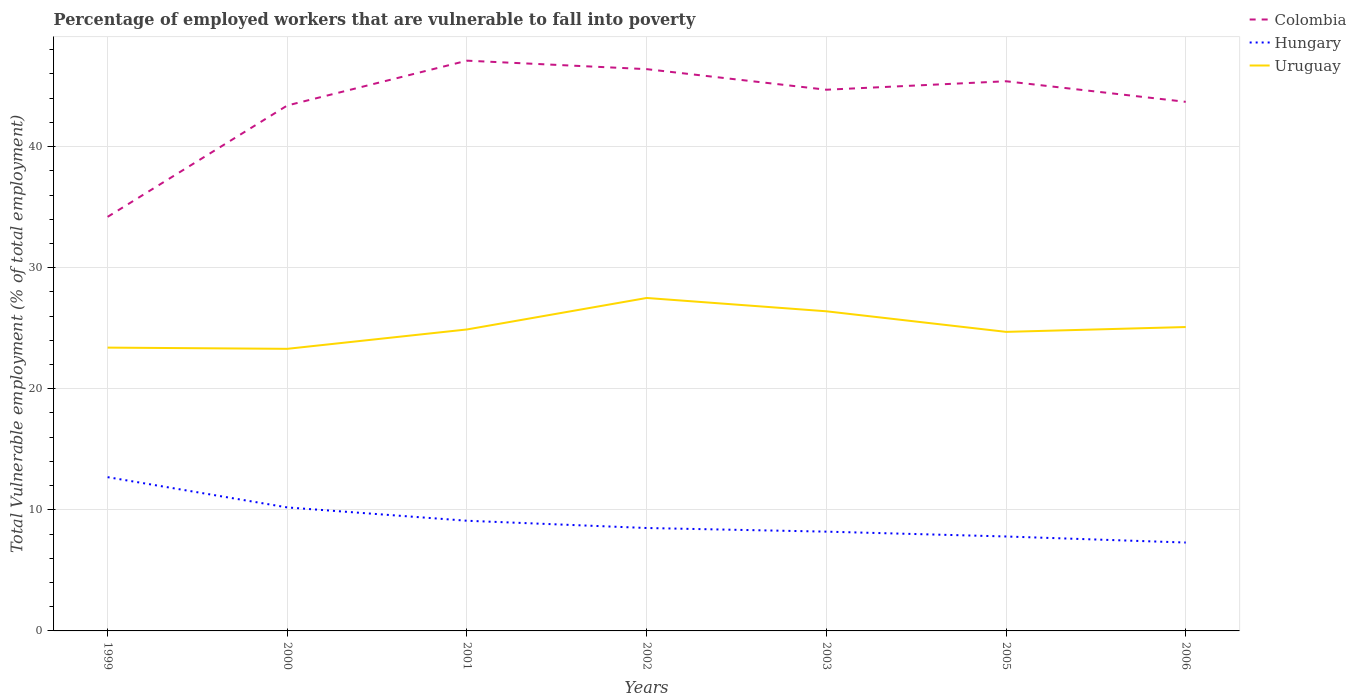How many different coloured lines are there?
Offer a terse response. 3. Does the line corresponding to Colombia intersect with the line corresponding to Hungary?
Offer a very short reply. No. Is the number of lines equal to the number of legend labels?
Ensure brevity in your answer.  Yes. Across all years, what is the maximum percentage of employed workers who are vulnerable to fall into poverty in Uruguay?
Your response must be concise. 23.3. In which year was the percentage of employed workers who are vulnerable to fall into poverty in Colombia maximum?
Offer a very short reply. 1999. What is the total percentage of employed workers who are vulnerable to fall into poverty in Uruguay in the graph?
Your answer should be compact. 1.1. What is the difference between the highest and the second highest percentage of employed workers who are vulnerable to fall into poverty in Hungary?
Offer a very short reply. 5.4. How many years are there in the graph?
Keep it short and to the point. 7. What is the difference between two consecutive major ticks on the Y-axis?
Offer a terse response. 10. Does the graph contain grids?
Keep it short and to the point. Yes. Where does the legend appear in the graph?
Your response must be concise. Top right. How are the legend labels stacked?
Give a very brief answer. Vertical. What is the title of the graph?
Provide a short and direct response. Percentage of employed workers that are vulnerable to fall into poverty. Does "India" appear as one of the legend labels in the graph?
Give a very brief answer. No. What is the label or title of the Y-axis?
Offer a terse response. Total Vulnerable employment (% of total employment). What is the Total Vulnerable employment (% of total employment) in Colombia in 1999?
Give a very brief answer. 34.2. What is the Total Vulnerable employment (% of total employment) in Hungary in 1999?
Provide a succinct answer. 12.7. What is the Total Vulnerable employment (% of total employment) of Uruguay in 1999?
Your answer should be very brief. 23.4. What is the Total Vulnerable employment (% of total employment) of Colombia in 2000?
Keep it short and to the point. 43.4. What is the Total Vulnerable employment (% of total employment) in Hungary in 2000?
Your response must be concise. 10.2. What is the Total Vulnerable employment (% of total employment) in Uruguay in 2000?
Keep it short and to the point. 23.3. What is the Total Vulnerable employment (% of total employment) of Colombia in 2001?
Make the answer very short. 47.1. What is the Total Vulnerable employment (% of total employment) of Hungary in 2001?
Give a very brief answer. 9.1. What is the Total Vulnerable employment (% of total employment) in Uruguay in 2001?
Keep it short and to the point. 24.9. What is the Total Vulnerable employment (% of total employment) of Colombia in 2002?
Offer a terse response. 46.4. What is the Total Vulnerable employment (% of total employment) in Hungary in 2002?
Provide a succinct answer. 8.5. What is the Total Vulnerable employment (% of total employment) in Colombia in 2003?
Ensure brevity in your answer.  44.7. What is the Total Vulnerable employment (% of total employment) of Hungary in 2003?
Make the answer very short. 8.2. What is the Total Vulnerable employment (% of total employment) in Uruguay in 2003?
Make the answer very short. 26.4. What is the Total Vulnerable employment (% of total employment) in Colombia in 2005?
Provide a succinct answer. 45.4. What is the Total Vulnerable employment (% of total employment) of Hungary in 2005?
Provide a short and direct response. 7.8. What is the Total Vulnerable employment (% of total employment) in Uruguay in 2005?
Your answer should be very brief. 24.7. What is the Total Vulnerable employment (% of total employment) in Colombia in 2006?
Keep it short and to the point. 43.7. What is the Total Vulnerable employment (% of total employment) of Hungary in 2006?
Your answer should be compact. 7.3. What is the Total Vulnerable employment (% of total employment) of Uruguay in 2006?
Ensure brevity in your answer.  25.1. Across all years, what is the maximum Total Vulnerable employment (% of total employment) of Colombia?
Offer a terse response. 47.1. Across all years, what is the maximum Total Vulnerable employment (% of total employment) in Hungary?
Make the answer very short. 12.7. Across all years, what is the maximum Total Vulnerable employment (% of total employment) of Uruguay?
Provide a short and direct response. 27.5. Across all years, what is the minimum Total Vulnerable employment (% of total employment) in Colombia?
Your response must be concise. 34.2. Across all years, what is the minimum Total Vulnerable employment (% of total employment) in Hungary?
Offer a very short reply. 7.3. Across all years, what is the minimum Total Vulnerable employment (% of total employment) in Uruguay?
Your answer should be compact. 23.3. What is the total Total Vulnerable employment (% of total employment) of Colombia in the graph?
Provide a short and direct response. 304.9. What is the total Total Vulnerable employment (% of total employment) of Hungary in the graph?
Your response must be concise. 63.8. What is the total Total Vulnerable employment (% of total employment) in Uruguay in the graph?
Offer a terse response. 175.3. What is the difference between the Total Vulnerable employment (% of total employment) of Colombia in 1999 and that in 2000?
Ensure brevity in your answer.  -9.2. What is the difference between the Total Vulnerable employment (% of total employment) of Uruguay in 1999 and that in 2000?
Ensure brevity in your answer.  0.1. What is the difference between the Total Vulnerable employment (% of total employment) of Colombia in 1999 and that in 2001?
Provide a short and direct response. -12.9. What is the difference between the Total Vulnerable employment (% of total employment) of Hungary in 1999 and that in 2001?
Ensure brevity in your answer.  3.6. What is the difference between the Total Vulnerable employment (% of total employment) in Colombia in 1999 and that in 2002?
Your response must be concise. -12.2. What is the difference between the Total Vulnerable employment (% of total employment) in Hungary in 1999 and that in 2002?
Your answer should be very brief. 4.2. What is the difference between the Total Vulnerable employment (% of total employment) in Uruguay in 1999 and that in 2002?
Keep it short and to the point. -4.1. What is the difference between the Total Vulnerable employment (% of total employment) of Colombia in 1999 and that in 2003?
Your response must be concise. -10.5. What is the difference between the Total Vulnerable employment (% of total employment) of Hungary in 1999 and that in 2005?
Offer a very short reply. 4.9. What is the difference between the Total Vulnerable employment (% of total employment) in Colombia in 1999 and that in 2006?
Your answer should be very brief. -9.5. What is the difference between the Total Vulnerable employment (% of total employment) of Hungary in 1999 and that in 2006?
Your response must be concise. 5.4. What is the difference between the Total Vulnerable employment (% of total employment) in Colombia in 2000 and that in 2001?
Provide a succinct answer. -3.7. What is the difference between the Total Vulnerable employment (% of total employment) in Hungary in 2000 and that in 2001?
Make the answer very short. 1.1. What is the difference between the Total Vulnerable employment (% of total employment) of Uruguay in 2000 and that in 2001?
Give a very brief answer. -1.6. What is the difference between the Total Vulnerable employment (% of total employment) of Colombia in 2000 and that in 2002?
Make the answer very short. -3. What is the difference between the Total Vulnerable employment (% of total employment) in Hungary in 2000 and that in 2002?
Make the answer very short. 1.7. What is the difference between the Total Vulnerable employment (% of total employment) of Uruguay in 2000 and that in 2002?
Your answer should be very brief. -4.2. What is the difference between the Total Vulnerable employment (% of total employment) in Hungary in 2000 and that in 2005?
Provide a succinct answer. 2.4. What is the difference between the Total Vulnerable employment (% of total employment) of Colombia in 2000 and that in 2006?
Offer a very short reply. -0.3. What is the difference between the Total Vulnerable employment (% of total employment) of Hungary in 2001 and that in 2002?
Give a very brief answer. 0.6. What is the difference between the Total Vulnerable employment (% of total employment) in Uruguay in 2001 and that in 2002?
Your answer should be compact. -2.6. What is the difference between the Total Vulnerable employment (% of total employment) of Colombia in 2001 and that in 2003?
Your answer should be very brief. 2.4. What is the difference between the Total Vulnerable employment (% of total employment) of Uruguay in 2001 and that in 2003?
Make the answer very short. -1.5. What is the difference between the Total Vulnerable employment (% of total employment) in Hungary in 2001 and that in 2005?
Your response must be concise. 1.3. What is the difference between the Total Vulnerable employment (% of total employment) of Uruguay in 2001 and that in 2005?
Your response must be concise. 0.2. What is the difference between the Total Vulnerable employment (% of total employment) in Uruguay in 2001 and that in 2006?
Ensure brevity in your answer.  -0.2. What is the difference between the Total Vulnerable employment (% of total employment) of Colombia in 2002 and that in 2003?
Your answer should be very brief. 1.7. What is the difference between the Total Vulnerable employment (% of total employment) in Colombia in 2002 and that in 2005?
Make the answer very short. 1. What is the difference between the Total Vulnerable employment (% of total employment) in Uruguay in 2002 and that in 2005?
Make the answer very short. 2.8. What is the difference between the Total Vulnerable employment (% of total employment) of Hungary in 2002 and that in 2006?
Provide a short and direct response. 1.2. What is the difference between the Total Vulnerable employment (% of total employment) of Hungary in 2003 and that in 2005?
Provide a short and direct response. 0.4. What is the difference between the Total Vulnerable employment (% of total employment) of Colombia in 2003 and that in 2006?
Give a very brief answer. 1. What is the difference between the Total Vulnerable employment (% of total employment) in Uruguay in 2003 and that in 2006?
Your response must be concise. 1.3. What is the difference between the Total Vulnerable employment (% of total employment) of Colombia in 2005 and that in 2006?
Your answer should be compact. 1.7. What is the difference between the Total Vulnerable employment (% of total employment) in Hungary in 2005 and that in 2006?
Offer a terse response. 0.5. What is the difference between the Total Vulnerable employment (% of total employment) in Uruguay in 2005 and that in 2006?
Provide a succinct answer. -0.4. What is the difference between the Total Vulnerable employment (% of total employment) of Colombia in 1999 and the Total Vulnerable employment (% of total employment) of Hungary in 2000?
Your answer should be very brief. 24. What is the difference between the Total Vulnerable employment (% of total employment) in Colombia in 1999 and the Total Vulnerable employment (% of total employment) in Uruguay in 2000?
Your answer should be very brief. 10.9. What is the difference between the Total Vulnerable employment (% of total employment) of Hungary in 1999 and the Total Vulnerable employment (% of total employment) of Uruguay in 2000?
Provide a succinct answer. -10.6. What is the difference between the Total Vulnerable employment (% of total employment) in Colombia in 1999 and the Total Vulnerable employment (% of total employment) in Hungary in 2001?
Ensure brevity in your answer.  25.1. What is the difference between the Total Vulnerable employment (% of total employment) in Hungary in 1999 and the Total Vulnerable employment (% of total employment) in Uruguay in 2001?
Give a very brief answer. -12.2. What is the difference between the Total Vulnerable employment (% of total employment) of Colombia in 1999 and the Total Vulnerable employment (% of total employment) of Hungary in 2002?
Provide a short and direct response. 25.7. What is the difference between the Total Vulnerable employment (% of total employment) of Colombia in 1999 and the Total Vulnerable employment (% of total employment) of Uruguay in 2002?
Your answer should be compact. 6.7. What is the difference between the Total Vulnerable employment (% of total employment) in Hungary in 1999 and the Total Vulnerable employment (% of total employment) in Uruguay in 2002?
Ensure brevity in your answer.  -14.8. What is the difference between the Total Vulnerable employment (% of total employment) of Colombia in 1999 and the Total Vulnerable employment (% of total employment) of Hungary in 2003?
Offer a terse response. 26. What is the difference between the Total Vulnerable employment (% of total employment) in Hungary in 1999 and the Total Vulnerable employment (% of total employment) in Uruguay in 2003?
Offer a very short reply. -13.7. What is the difference between the Total Vulnerable employment (% of total employment) of Colombia in 1999 and the Total Vulnerable employment (% of total employment) of Hungary in 2005?
Ensure brevity in your answer.  26.4. What is the difference between the Total Vulnerable employment (% of total employment) of Hungary in 1999 and the Total Vulnerable employment (% of total employment) of Uruguay in 2005?
Give a very brief answer. -12. What is the difference between the Total Vulnerable employment (% of total employment) of Colombia in 1999 and the Total Vulnerable employment (% of total employment) of Hungary in 2006?
Your answer should be compact. 26.9. What is the difference between the Total Vulnerable employment (% of total employment) of Colombia in 1999 and the Total Vulnerable employment (% of total employment) of Uruguay in 2006?
Make the answer very short. 9.1. What is the difference between the Total Vulnerable employment (% of total employment) in Colombia in 2000 and the Total Vulnerable employment (% of total employment) in Hungary in 2001?
Offer a terse response. 34.3. What is the difference between the Total Vulnerable employment (% of total employment) of Hungary in 2000 and the Total Vulnerable employment (% of total employment) of Uruguay in 2001?
Offer a terse response. -14.7. What is the difference between the Total Vulnerable employment (% of total employment) in Colombia in 2000 and the Total Vulnerable employment (% of total employment) in Hungary in 2002?
Give a very brief answer. 34.9. What is the difference between the Total Vulnerable employment (% of total employment) in Colombia in 2000 and the Total Vulnerable employment (% of total employment) in Uruguay in 2002?
Offer a very short reply. 15.9. What is the difference between the Total Vulnerable employment (% of total employment) of Hungary in 2000 and the Total Vulnerable employment (% of total employment) of Uruguay in 2002?
Give a very brief answer. -17.3. What is the difference between the Total Vulnerable employment (% of total employment) in Colombia in 2000 and the Total Vulnerable employment (% of total employment) in Hungary in 2003?
Offer a very short reply. 35.2. What is the difference between the Total Vulnerable employment (% of total employment) of Colombia in 2000 and the Total Vulnerable employment (% of total employment) of Uruguay in 2003?
Your answer should be very brief. 17. What is the difference between the Total Vulnerable employment (% of total employment) of Hungary in 2000 and the Total Vulnerable employment (% of total employment) of Uruguay in 2003?
Offer a very short reply. -16.2. What is the difference between the Total Vulnerable employment (% of total employment) of Colombia in 2000 and the Total Vulnerable employment (% of total employment) of Hungary in 2005?
Make the answer very short. 35.6. What is the difference between the Total Vulnerable employment (% of total employment) of Colombia in 2000 and the Total Vulnerable employment (% of total employment) of Uruguay in 2005?
Offer a very short reply. 18.7. What is the difference between the Total Vulnerable employment (% of total employment) in Hungary in 2000 and the Total Vulnerable employment (% of total employment) in Uruguay in 2005?
Your response must be concise. -14.5. What is the difference between the Total Vulnerable employment (% of total employment) of Colombia in 2000 and the Total Vulnerable employment (% of total employment) of Hungary in 2006?
Offer a terse response. 36.1. What is the difference between the Total Vulnerable employment (% of total employment) of Colombia in 2000 and the Total Vulnerable employment (% of total employment) of Uruguay in 2006?
Ensure brevity in your answer.  18.3. What is the difference between the Total Vulnerable employment (% of total employment) in Hungary in 2000 and the Total Vulnerable employment (% of total employment) in Uruguay in 2006?
Provide a succinct answer. -14.9. What is the difference between the Total Vulnerable employment (% of total employment) in Colombia in 2001 and the Total Vulnerable employment (% of total employment) in Hungary in 2002?
Your response must be concise. 38.6. What is the difference between the Total Vulnerable employment (% of total employment) in Colombia in 2001 and the Total Vulnerable employment (% of total employment) in Uruguay in 2002?
Your response must be concise. 19.6. What is the difference between the Total Vulnerable employment (% of total employment) in Hungary in 2001 and the Total Vulnerable employment (% of total employment) in Uruguay in 2002?
Ensure brevity in your answer.  -18.4. What is the difference between the Total Vulnerable employment (% of total employment) in Colombia in 2001 and the Total Vulnerable employment (% of total employment) in Hungary in 2003?
Your answer should be very brief. 38.9. What is the difference between the Total Vulnerable employment (% of total employment) of Colombia in 2001 and the Total Vulnerable employment (% of total employment) of Uruguay in 2003?
Provide a short and direct response. 20.7. What is the difference between the Total Vulnerable employment (% of total employment) of Hungary in 2001 and the Total Vulnerable employment (% of total employment) of Uruguay in 2003?
Make the answer very short. -17.3. What is the difference between the Total Vulnerable employment (% of total employment) in Colombia in 2001 and the Total Vulnerable employment (% of total employment) in Hungary in 2005?
Make the answer very short. 39.3. What is the difference between the Total Vulnerable employment (% of total employment) in Colombia in 2001 and the Total Vulnerable employment (% of total employment) in Uruguay in 2005?
Provide a short and direct response. 22.4. What is the difference between the Total Vulnerable employment (% of total employment) in Hungary in 2001 and the Total Vulnerable employment (% of total employment) in Uruguay in 2005?
Give a very brief answer. -15.6. What is the difference between the Total Vulnerable employment (% of total employment) in Colombia in 2001 and the Total Vulnerable employment (% of total employment) in Hungary in 2006?
Provide a succinct answer. 39.8. What is the difference between the Total Vulnerable employment (% of total employment) of Hungary in 2001 and the Total Vulnerable employment (% of total employment) of Uruguay in 2006?
Your answer should be compact. -16. What is the difference between the Total Vulnerable employment (% of total employment) of Colombia in 2002 and the Total Vulnerable employment (% of total employment) of Hungary in 2003?
Provide a short and direct response. 38.2. What is the difference between the Total Vulnerable employment (% of total employment) of Colombia in 2002 and the Total Vulnerable employment (% of total employment) of Uruguay in 2003?
Provide a short and direct response. 20. What is the difference between the Total Vulnerable employment (% of total employment) of Hungary in 2002 and the Total Vulnerable employment (% of total employment) of Uruguay in 2003?
Your answer should be very brief. -17.9. What is the difference between the Total Vulnerable employment (% of total employment) of Colombia in 2002 and the Total Vulnerable employment (% of total employment) of Hungary in 2005?
Give a very brief answer. 38.6. What is the difference between the Total Vulnerable employment (% of total employment) of Colombia in 2002 and the Total Vulnerable employment (% of total employment) of Uruguay in 2005?
Your answer should be very brief. 21.7. What is the difference between the Total Vulnerable employment (% of total employment) in Hungary in 2002 and the Total Vulnerable employment (% of total employment) in Uruguay in 2005?
Give a very brief answer. -16.2. What is the difference between the Total Vulnerable employment (% of total employment) of Colombia in 2002 and the Total Vulnerable employment (% of total employment) of Hungary in 2006?
Make the answer very short. 39.1. What is the difference between the Total Vulnerable employment (% of total employment) in Colombia in 2002 and the Total Vulnerable employment (% of total employment) in Uruguay in 2006?
Your answer should be compact. 21.3. What is the difference between the Total Vulnerable employment (% of total employment) of Hungary in 2002 and the Total Vulnerable employment (% of total employment) of Uruguay in 2006?
Your answer should be compact. -16.6. What is the difference between the Total Vulnerable employment (% of total employment) in Colombia in 2003 and the Total Vulnerable employment (% of total employment) in Hungary in 2005?
Provide a short and direct response. 36.9. What is the difference between the Total Vulnerable employment (% of total employment) of Hungary in 2003 and the Total Vulnerable employment (% of total employment) of Uruguay in 2005?
Provide a succinct answer. -16.5. What is the difference between the Total Vulnerable employment (% of total employment) in Colombia in 2003 and the Total Vulnerable employment (% of total employment) in Hungary in 2006?
Give a very brief answer. 37.4. What is the difference between the Total Vulnerable employment (% of total employment) in Colombia in 2003 and the Total Vulnerable employment (% of total employment) in Uruguay in 2006?
Give a very brief answer. 19.6. What is the difference between the Total Vulnerable employment (% of total employment) of Hungary in 2003 and the Total Vulnerable employment (% of total employment) of Uruguay in 2006?
Give a very brief answer. -16.9. What is the difference between the Total Vulnerable employment (% of total employment) of Colombia in 2005 and the Total Vulnerable employment (% of total employment) of Hungary in 2006?
Keep it short and to the point. 38.1. What is the difference between the Total Vulnerable employment (% of total employment) in Colombia in 2005 and the Total Vulnerable employment (% of total employment) in Uruguay in 2006?
Your response must be concise. 20.3. What is the difference between the Total Vulnerable employment (% of total employment) of Hungary in 2005 and the Total Vulnerable employment (% of total employment) of Uruguay in 2006?
Keep it short and to the point. -17.3. What is the average Total Vulnerable employment (% of total employment) of Colombia per year?
Ensure brevity in your answer.  43.56. What is the average Total Vulnerable employment (% of total employment) of Hungary per year?
Your answer should be compact. 9.11. What is the average Total Vulnerable employment (% of total employment) in Uruguay per year?
Offer a very short reply. 25.04. In the year 1999, what is the difference between the Total Vulnerable employment (% of total employment) in Colombia and Total Vulnerable employment (% of total employment) in Hungary?
Your response must be concise. 21.5. In the year 1999, what is the difference between the Total Vulnerable employment (% of total employment) of Colombia and Total Vulnerable employment (% of total employment) of Uruguay?
Make the answer very short. 10.8. In the year 2000, what is the difference between the Total Vulnerable employment (% of total employment) of Colombia and Total Vulnerable employment (% of total employment) of Hungary?
Your answer should be very brief. 33.2. In the year 2000, what is the difference between the Total Vulnerable employment (% of total employment) of Colombia and Total Vulnerable employment (% of total employment) of Uruguay?
Offer a very short reply. 20.1. In the year 2001, what is the difference between the Total Vulnerable employment (% of total employment) in Colombia and Total Vulnerable employment (% of total employment) in Uruguay?
Ensure brevity in your answer.  22.2. In the year 2001, what is the difference between the Total Vulnerable employment (% of total employment) in Hungary and Total Vulnerable employment (% of total employment) in Uruguay?
Offer a terse response. -15.8. In the year 2002, what is the difference between the Total Vulnerable employment (% of total employment) in Colombia and Total Vulnerable employment (% of total employment) in Hungary?
Your response must be concise. 37.9. In the year 2002, what is the difference between the Total Vulnerable employment (% of total employment) in Colombia and Total Vulnerable employment (% of total employment) in Uruguay?
Offer a very short reply. 18.9. In the year 2003, what is the difference between the Total Vulnerable employment (% of total employment) of Colombia and Total Vulnerable employment (% of total employment) of Hungary?
Your response must be concise. 36.5. In the year 2003, what is the difference between the Total Vulnerable employment (% of total employment) of Hungary and Total Vulnerable employment (% of total employment) of Uruguay?
Ensure brevity in your answer.  -18.2. In the year 2005, what is the difference between the Total Vulnerable employment (% of total employment) of Colombia and Total Vulnerable employment (% of total employment) of Hungary?
Your answer should be compact. 37.6. In the year 2005, what is the difference between the Total Vulnerable employment (% of total employment) in Colombia and Total Vulnerable employment (% of total employment) in Uruguay?
Your answer should be compact. 20.7. In the year 2005, what is the difference between the Total Vulnerable employment (% of total employment) in Hungary and Total Vulnerable employment (% of total employment) in Uruguay?
Give a very brief answer. -16.9. In the year 2006, what is the difference between the Total Vulnerable employment (% of total employment) of Colombia and Total Vulnerable employment (% of total employment) of Hungary?
Give a very brief answer. 36.4. In the year 2006, what is the difference between the Total Vulnerable employment (% of total employment) of Colombia and Total Vulnerable employment (% of total employment) of Uruguay?
Offer a terse response. 18.6. In the year 2006, what is the difference between the Total Vulnerable employment (% of total employment) of Hungary and Total Vulnerable employment (% of total employment) of Uruguay?
Keep it short and to the point. -17.8. What is the ratio of the Total Vulnerable employment (% of total employment) in Colombia in 1999 to that in 2000?
Make the answer very short. 0.79. What is the ratio of the Total Vulnerable employment (% of total employment) in Hungary in 1999 to that in 2000?
Your answer should be very brief. 1.25. What is the ratio of the Total Vulnerable employment (% of total employment) in Colombia in 1999 to that in 2001?
Provide a short and direct response. 0.73. What is the ratio of the Total Vulnerable employment (% of total employment) of Hungary in 1999 to that in 2001?
Provide a short and direct response. 1.4. What is the ratio of the Total Vulnerable employment (% of total employment) of Uruguay in 1999 to that in 2001?
Give a very brief answer. 0.94. What is the ratio of the Total Vulnerable employment (% of total employment) in Colombia in 1999 to that in 2002?
Your answer should be compact. 0.74. What is the ratio of the Total Vulnerable employment (% of total employment) in Hungary in 1999 to that in 2002?
Provide a short and direct response. 1.49. What is the ratio of the Total Vulnerable employment (% of total employment) of Uruguay in 1999 to that in 2002?
Your response must be concise. 0.85. What is the ratio of the Total Vulnerable employment (% of total employment) of Colombia in 1999 to that in 2003?
Your response must be concise. 0.77. What is the ratio of the Total Vulnerable employment (% of total employment) of Hungary in 1999 to that in 2003?
Your response must be concise. 1.55. What is the ratio of the Total Vulnerable employment (% of total employment) of Uruguay in 1999 to that in 2003?
Your answer should be compact. 0.89. What is the ratio of the Total Vulnerable employment (% of total employment) of Colombia in 1999 to that in 2005?
Give a very brief answer. 0.75. What is the ratio of the Total Vulnerable employment (% of total employment) of Hungary in 1999 to that in 2005?
Provide a succinct answer. 1.63. What is the ratio of the Total Vulnerable employment (% of total employment) of Uruguay in 1999 to that in 2005?
Make the answer very short. 0.95. What is the ratio of the Total Vulnerable employment (% of total employment) of Colombia in 1999 to that in 2006?
Your answer should be compact. 0.78. What is the ratio of the Total Vulnerable employment (% of total employment) in Hungary in 1999 to that in 2006?
Offer a very short reply. 1.74. What is the ratio of the Total Vulnerable employment (% of total employment) in Uruguay in 1999 to that in 2006?
Provide a succinct answer. 0.93. What is the ratio of the Total Vulnerable employment (% of total employment) of Colombia in 2000 to that in 2001?
Provide a succinct answer. 0.92. What is the ratio of the Total Vulnerable employment (% of total employment) of Hungary in 2000 to that in 2001?
Your answer should be very brief. 1.12. What is the ratio of the Total Vulnerable employment (% of total employment) of Uruguay in 2000 to that in 2001?
Ensure brevity in your answer.  0.94. What is the ratio of the Total Vulnerable employment (% of total employment) in Colombia in 2000 to that in 2002?
Offer a terse response. 0.94. What is the ratio of the Total Vulnerable employment (% of total employment) in Uruguay in 2000 to that in 2002?
Keep it short and to the point. 0.85. What is the ratio of the Total Vulnerable employment (% of total employment) in Colombia in 2000 to that in 2003?
Offer a terse response. 0.97. What is the ratio of the Total Vulnerable employment (% of total employment) of Hungary in 2000 to that in 2003?
Make the answer very short. 1.24. What is the ratio of the Total Vulnerable employment (% of total employment) in Uruguay in 2000 to that in 2003?
Make the answer very short. 0.88. What is the ratio of the Total Vulnerable employment (% of total employment) in Colombia in 2000 to that in 2005?
Offer a terse response. 0.96. What is the ratio of the Total Vulnerable employment (% of total employment) in Hungary in 2000 to that in 2005?
Your answer should be compact. 1.31. What is the ratio of the Total Vulnerable employment (% of total employment) in Uruguay in 2000 to that in 2005?
Keep it short and to the point. 0.94. What is the ratio of the Total Vulnerable employment (% of total employment) of Colombia in 2000 to that in 2006?
Provide a succinct answer. 0.99. What is the ratio of the Total Vulnerable employment (% of total employment) of Hungary in 2000 to that in 2006?
Offer a terse response. 1.4. What is the ratio of the Total Vulnerable employment (% of total employment) of Uruguay in 2000 to that in 2006?
Provide a short and direct response. 0.93. What is the ratio of the Total Vulnerable employment (% of total employment) in Colombia in 2001 to that in 2002?
Your answer should be compact. 1.02. What is the ratio of the Total Vulnerable employment (% of total employment) of Hungary in 2001 to that in 2002?
Offer a terse response. 1.07. What is the ratio of the Total Vulnerable employment (% of total employment) in Uruguay in 2001 to that in 2002?
Your response must be concise. 0.91. What is the ratio of the Total Vulnerable employment (% of total employment) in Colombia in 2001 to that in 2003?
Provide a short and direct response. 1.05. What is the ratio of the Total Vulnerable employment (% of total employment) in Hungary in 2001 to that in 2003?
Ensure brevity in your answer.  1.11. What is the ratio of the Total Vulnerable employment (% of total employment) in Uruguay in 2001 to that in 2003?
Make the answer very short. 0.94. What is the ratio of the Total Vulnerable employment (% of total employment) in Colombia in 2001 to that in 2005?
Keep it short and to the point. 1.04. What is the ratio of the Total Vulnerable employment (% of total employment) in Hungary in 2001 to that in 2005?
Give a very brief answer. 1.17. What is the ratio of the Total Vulnerable employment (% of total employment) in Colombia in 2001 to that in 2006?
Keep it short and to the point. 1.08. What is the ratio of the Total Vulnerable employment (% of total employment) in Hungary in 2001 to that in 2006?
Provide a succinct answer. 1.25. What is the ratio of the Total Vulnerable employment (% of total employment) in Colombia in 2002 to that in 2003?
Provide a succinct answer. 1.04. What is the ratio of the Total Vulnerable employment (% of total employment) in Hungary in 2002 to that in 2003?
Offer a very short reply. 1.04. What is the ratio of the Total Vulnerable employment (% of total employment) in Uruguay in 2002 to that in 2003?
Offer a very short reply. 1.04. What is the ratio of the Total Vulnerable employment (% of total employment) in Hungary in 2002 to that in 2005?
Give a very brief answer. 1.09. What is the ratio of the Total Vulnerable employment (% of total employment) in Uruguay in 2002 to that in 2005?
Keep it short and to the point. 1.11. What is the ratio of the Total Vulnerable employment (% of total employment) of Colombia in 2002 to that in 2006?
Ensure brevity in your answer.  1.06. What is the ratio of the Total Vulnerable employment (% of total employment) of Hungary in 2002 to that in 2006?
Provide a short and direct response. 1.16. What is the ratio of the Total Vulnerable employment (% of total employment) in Uruguay in 2002 to that in 2006?
Provide a short and direct response. 1.1. What is the ratio of the Total Vulnerable employment (% of total employment) of Colombia in 2003 to that in 2005?
Offer a terse response. 0.98. What is the ratio of the Total Vulnerable employment (% of total employment) in Hungary in 2003 to that in 2005?
Keep it short and to the point. 1.05. What is the ratio of the Total Vulnerable employment (% of total employment) of Uruguay in 2003 to that in 2005?
Ensure brevity in your answer.  1.07. What is the ratio of the Total Vulnerable employment (% of total employment) in Colombia in 2003 to that in 2006?
Provide a succinct answer. 1.02. What is the ratio of the Total Vulnerable employment (% of total employment) of Hungary in 2003 to that in 2006?
Offer a very short reply. 1.12. What is the ratio of the Total Vulnerable employment (% of total employment) of Uruguay in 2003 to that in 2006?
Offer a very short reply. 1.05. What is the ratio of the Total Vulnerable employment (% of total employment) of Colombia in 2005 to that in 2006?
Offer a very short reply. 1.04. What is the ratio of the Total Vulnerable employment (% of total employment) in Hungary in 2005 to that in 2006?
Your answer should be very brief. 1.07. What is the ratio of the Total Vulnerable employment (% of total employment) in Uruguay in 2005 to that in 2006?
Provide a short and direct response. 0.98. What is the difference between the highest and the second highest Total Vulnerable employment (% of total employment) of Hungary?
Offer a very short reply. 2.5. What is the difference between the highest and the lowest Total Vulnerable employment (% of total employment) in Hungary?
Ensure brevity in your answer.  5.4. 